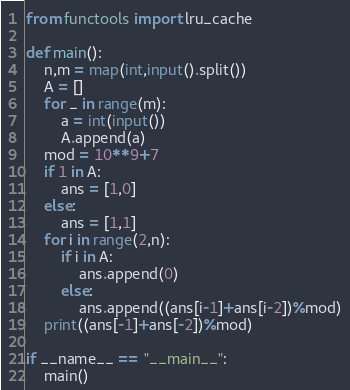<code> <loc_0><loc_0><loc_500><loc_500><_Python_>from functools import lru_cache

def main():
    n,m = map(int,input().split())
    A = []
    for _ in range(m):
        a = int(input())
        A.append(a)
    mod = 10**9+7
    if 1 in A:
        ans = [1,0]
    else:
        ans = [1,1]
    for i in range(2,n):
        if i in A:
            ans.append(0)
        else:
            ans.append((ans[i-1]+ans[i-2])%mod)
    print((ans[-1]+ans[-2])%mod)

if __name__ == "__main__":
    main()</code> 